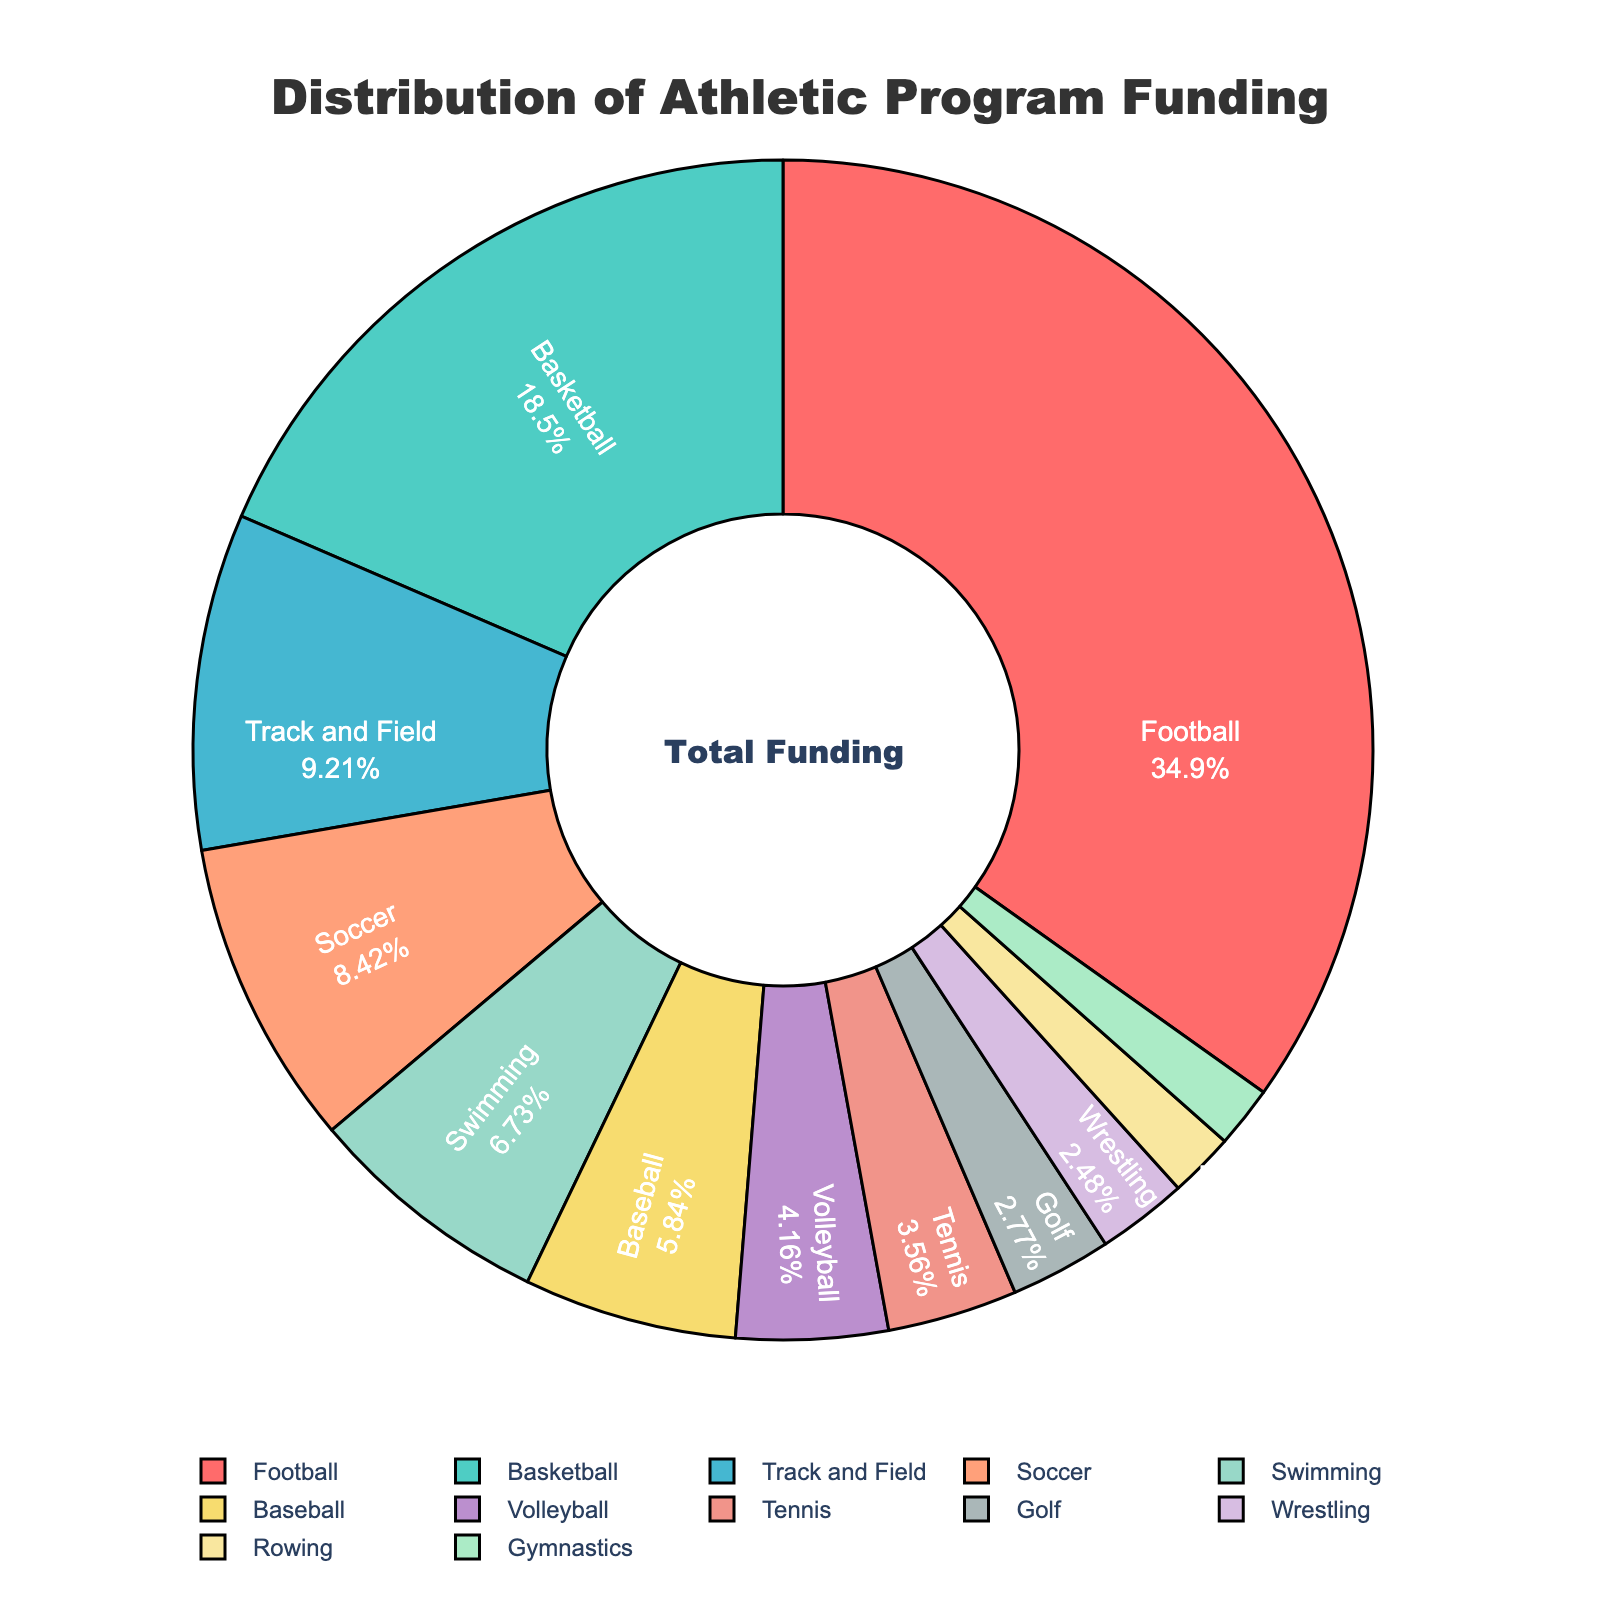What sport receives the highest percentage of funding? By looking at the largest segment in the pie chart, the sport with the biggest section represents the highest funding percentage. In this figure, football has the largest segment.
Answer: Football Which sport has the smallest slice in the pie chart, and what percentage does it represent? By comparing all the slices in the pie chart, the smallest slice denotes the sport with the least funding. The smallest slice here represents gymnastics at 1.7%.
Answer: Gymnastics at 1.7% How does the funding for basketball compare with that for soccer? To compare the funding percentages, you look at the size of the slices for basketball and soccer. Basketball's slice represents 18.7% of funding, while soccer's slice represents 8.5%.
Answer: Basketball has 10.2% more funding than Soccer What is the combined funding percentage for swimming, baseball, and volleyball? Sum the funding percentages for these sports: Swimming (6.8%), Baseball (5.9%), and Volleyball (4.2%). Thus, 6.8 + 5.9 + 4.2 = 16.9%.
Answer: 16.9% Do any sports have equal funding percentages? By examining the data segments, each slice should be checked for identical values. In this case, no two sports have the same funding percentage.
Answer: No Is football's funding more than double that of track and field? First, check football's percentage (35.2%) and track and field's percentage (9.3%). Doubling track and field's funding (9.3 * 2 = 18.6%) shows that football's funding (35.2%) is indeed more than double.
Answer: Yes What's the total funding percentage for the sports with less than 5% funding each? Add the percentages for Baseball (5.9%), Volleyball (4.2%), Tennis (3.6%), Golf (2.8%), Wrestling (2.5%), Rowing (1.8%), and Gymnastics (1.7%). Thus, 5.9 + 4.2 + 3.6 + 2.8 + 2.5 + 1.8 + 1.7 = 22.5%.
Answer: 22.5% How much more funding does football receive compared to swimming and rowing combined? First, sum the percentages for swimming (6.8%) and rowing (1.8%): 6.8 + 1.8 = 8.6%. Subtract this sum from football's percentage: 35.2 - 8.6 = 26.6%.
Answer: 26.6% What is the difference in funding percentage between the top-funded and the least-funded sport? Subtract the least-funded sport's percentage (Gymnastics at 1.7%) from the top-funded sport's percentage (Football at 35.2%): 35.2 - 1.7 = 33.5%.
Answer: 33.5% 